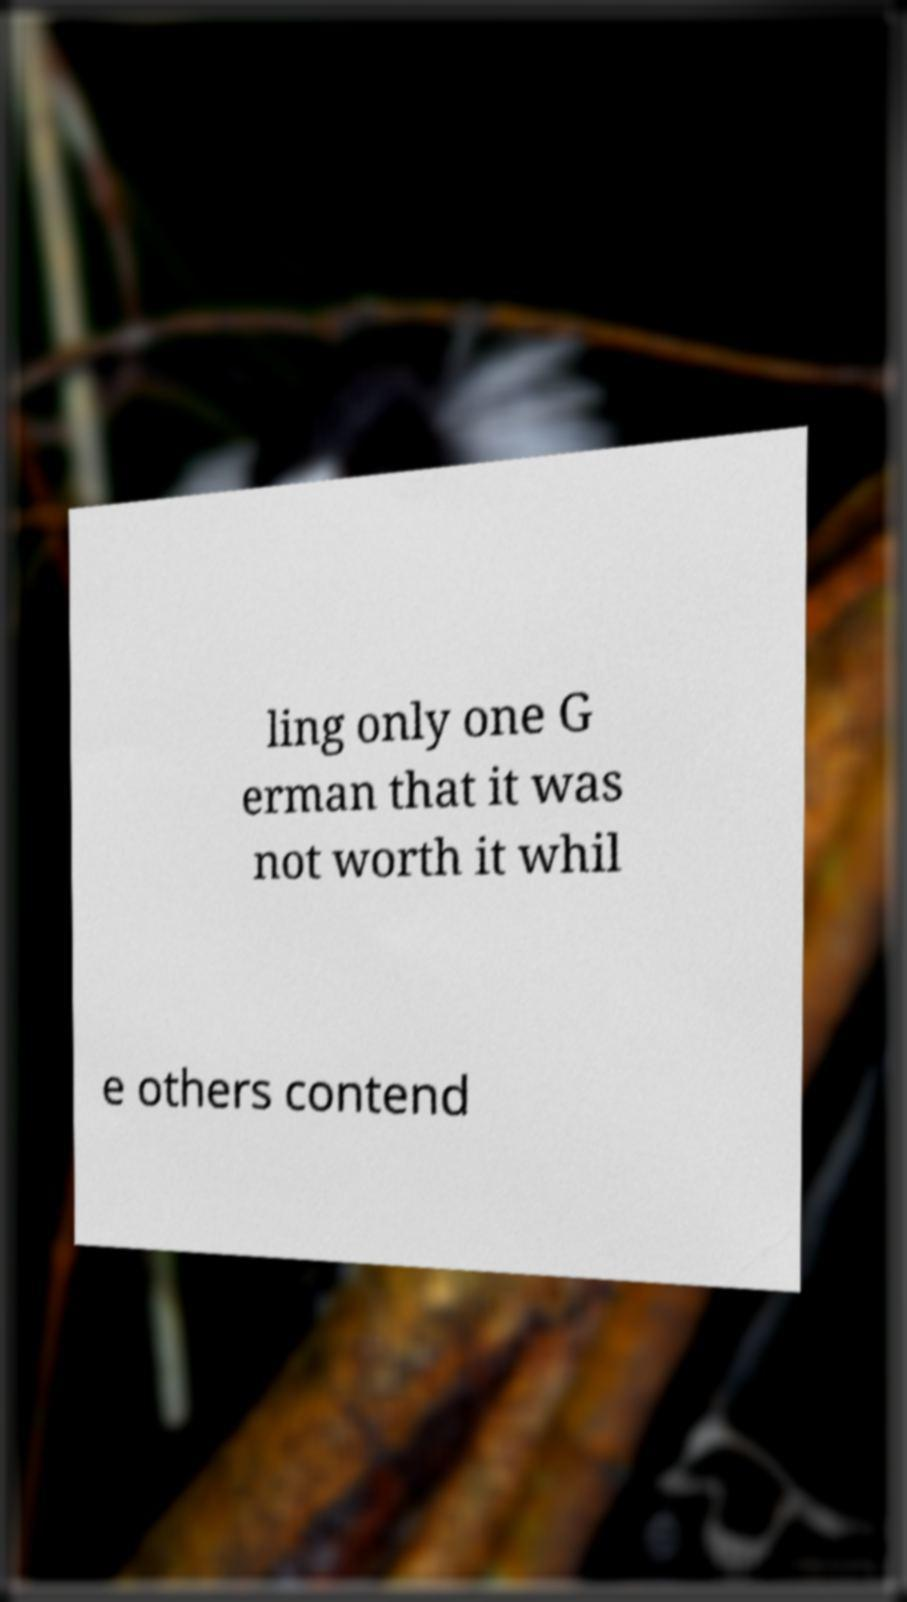Please read and relay the text visible in this image. What does it say? ling only one G erman that it was not worth it whil e others contend 